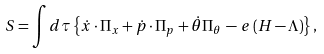Convert formula to latex. <formula><loc_0><loc_0><loc_500><loc_500>S = \int d \tau \left \{ \dot { x } \cdot \Pi _ { x } + \dot { p } \cdot \Pi _ { p } + \dot { \theta } \Pi _ { \theta } \, - \, e \left ( H - \Lambda \right ) \right \} ,</formula> 